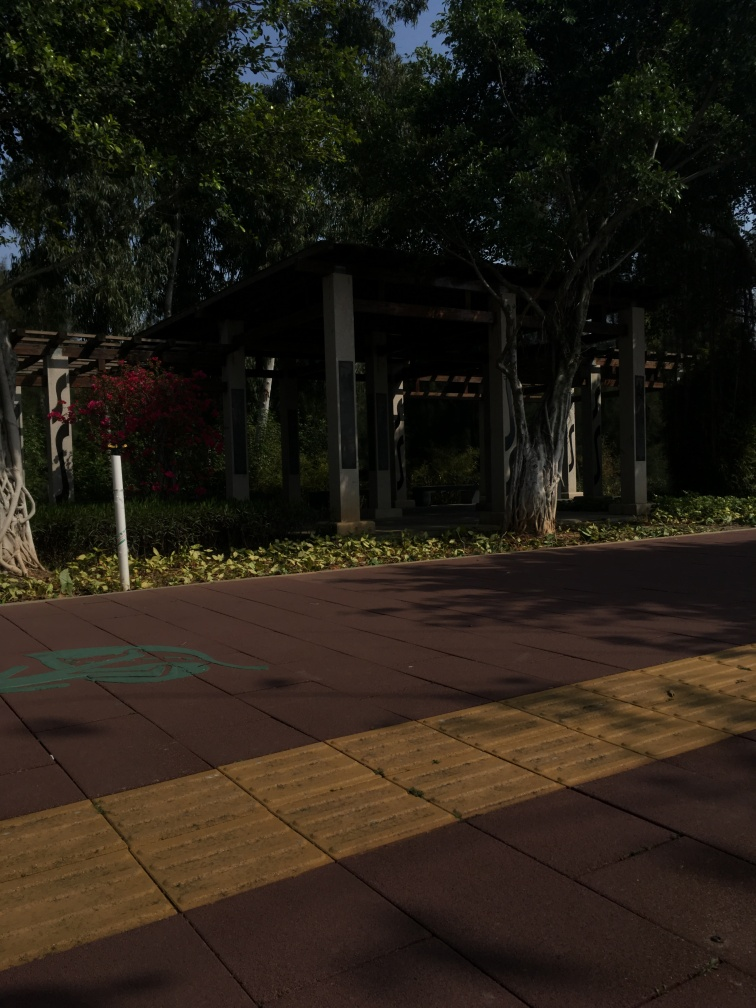Is there noise present in the image?
A. Yes
B. No
Answer with the option's letter from the given choices directly.
 A. 